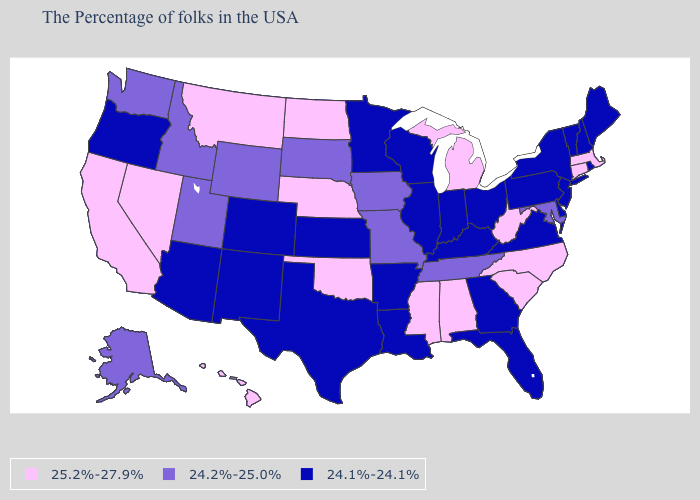What is the value of Alaska?
Answer briefly. 24.2%-25.0%. What is the highest value in states that border New York?
Concise answer only. 25.2%-27.9%. Name the states that have a value in the range 24.1%-24.1%?
Quick response, please. Maine, Rhode Island, New Hampshire, Vermont, New York, New Jersey, Delaware, Pennsylvania, Virginia, Ohio, Florida, Georgia, Kentucky, Indiana, Wisconsin, Illinois, Louisiana, Arkansas, Minnesota, Kansas, Texas, Colorado, New Mexico, Arizona, Oregon. Which states have the highest value in the USA?
Be succinct. Massachusetts, Connecticut, North Carolina, South Carolina, West Virginia, Michigan, Alabama, Mississippi, Nebraska, Oklahoma, North Dakota, Montana, Nevada, California, Hawaii. What is the value of Tennessee?
Give a very brief answer. 24.2%-25.0%. What is the value of Kansas?
Be succinct. 24.1%-24.1%. Name the states that have a value in the range 24.2%-25.0%?
Answer briefly. Maryland, Tennessee, Missouri, Iowa, South Dakota, Wyoming, Utah, Idaho, Washington, Alaska. Does Montana have the same value as Nebraska?
Be succinct. Yes. What is the value of South Carolina?
Quick response, please. 25.2%-27.9%. Does Nebraska have the lowest value in the MidWest?
Give a very brief answer. No. Which states hav the highest value in the Northeast?
Quick response, please. Massachusetts, Connecticut. Name the states that have a value in the range 25.2%-27.9%?
Concise answer only. Massachusetts, Connecticut, North Carolina, South Carolina, West Virginia, Michigan, Alabama, Mississippi, Nebraska, Oklahoma, North Dakota, Montana, Nevada, California, Hawaii. Name the states that have a value in the range 25.2%-27.9%?
Keep it brief. Massachusetts, Connecticut, North Carolina, South Carolina, West Virginia, Michigan, Alabama, Mississippi, Nebraska, Oklahoma, North Dakota, Montana, Nevada, California, Hawaii. Name the states that have a value in the range 24.1%-24.1%?
Write a very short answer. Maine, Rhode Island, New Hampshire, Vermont, New York, New Jersey, Delaware, Pennsylvania, Virginia, Ohio, Florida, Georgia, Kentucky, Indiana, Wisconsin, Illinois, Louisiana, Arkansas, Minnesota, Kansas, Texas, Colorado, New Mexico, Arizona, Oregon. Name the states that have a value in the range 24.1%-24.1%?
Concise answer only. Maine, Rhode Island, New Hampshire, Vermont, New York, New Jersey, Delaware, Pennsylvania, Virginia, Ohio, Florida, Georgia, Kentucky, Indiana, Wisconsin, Illinois, Louisiana, Arkansas, Minnesota, Kansas, Texas, Colorado, New Mexico, Arizona, Oregon. 